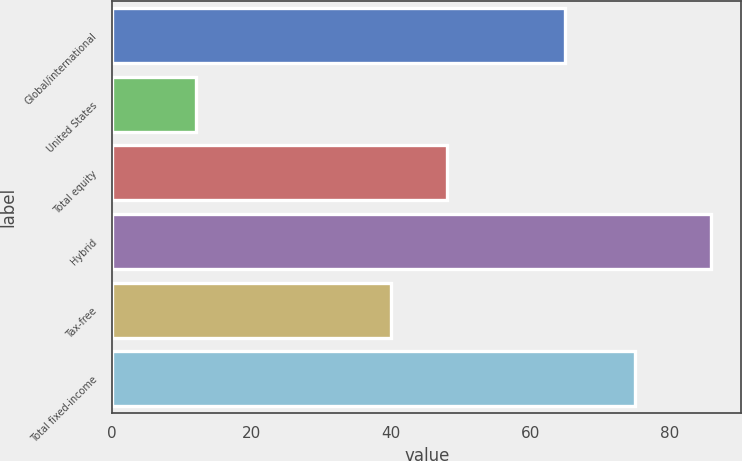Convert chart to OTSL. <chart><loc_0><loc_0><loc_500><loc_500><bar_chart><fcel>Global/international<fcel>United States<fcel>Total equity<fcel>Hybrid<fcel>Tax-free<fcel>Total fixed-income<nl><fcel>65<fcel>12<fcel>48<fcel>86<fcel>40<fcel>75<nl></chart> 